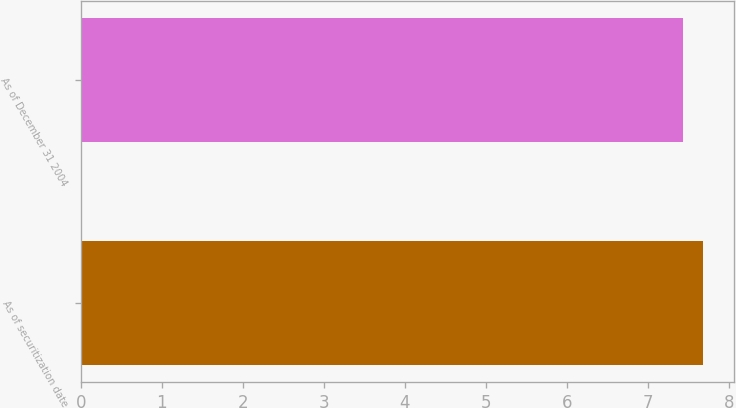<chart> <loc_0><loc_0><loc_500><loc_500><bar_chart><fcel>As of securitization date<fcel>As of December 31 2004<nl><fcel>7.68<fcel>7.43<nl></chart> 